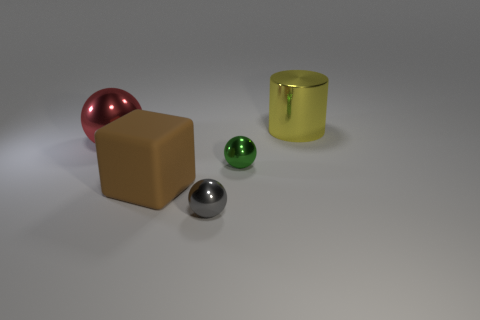Add 3 yellow shiny things. How many objects exist? 8 Subtract all blocks. How many objects are left? 4 Add 1 big cyan rubber blocks. How many big cyan rubber blocks exist? 1 Subtract 0 blue cubes. How many objects are left? 5 Subtract all gray spheres. Subtract all yellow metal cylinders. How many objects are left? 3 Add 4 big spheres. How many big spheres are left? 5 